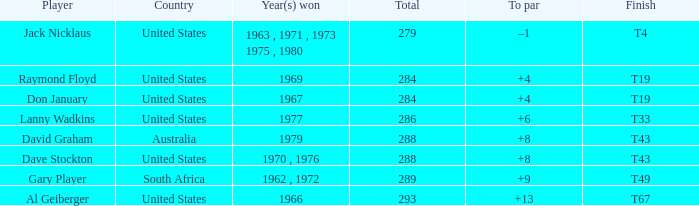Who won in 1979 with +8 to par? David Graham. 